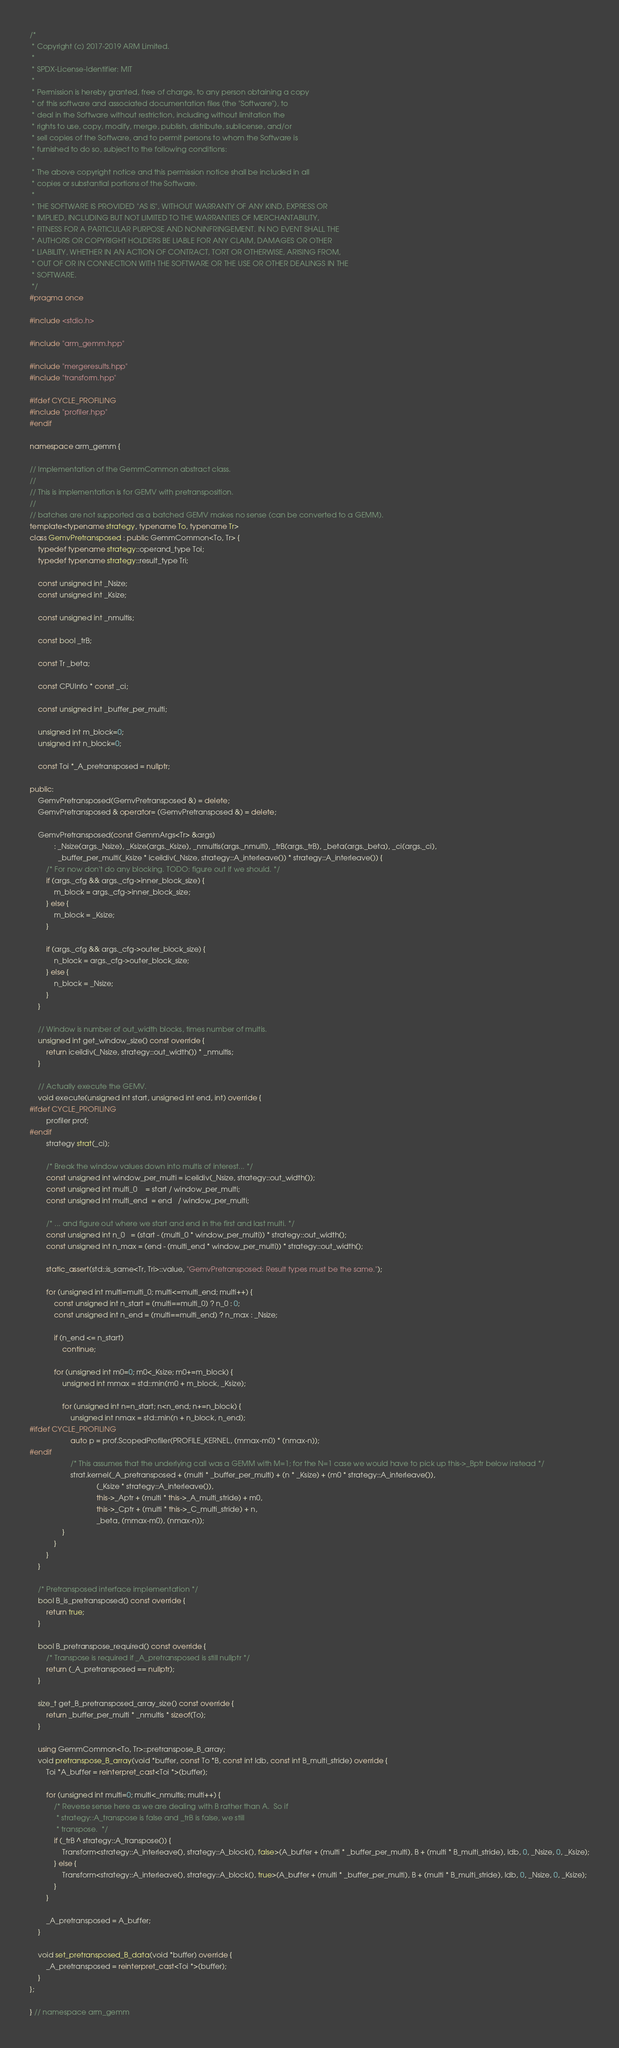<code> <loc_0><loc_0><loc_500><loc_500><_C++_>/*
 * Copyright (c) 2017-2019 ARM Limited.
 *
 * SPDX-License-Identifier: MIT
 *
 * Permission is hereby granted, free of charge, to any person obtaining a copy
 * of this software and associated documentation files (the "Software"), to
 * deal in the Software without restriction, including without limitation the
 * rights to use, copy, modify, merge, publish, distribute, sublicense, and/or
 * sell copies of the Software, and to permit persons to whom the Software is
 * furnished to do so, subject to the following conditions:
 *
 * The above copyright notice and this permission notice shall be included in all
 * copies or substantial portions of the Software.
 *
 * THE SOFTWARE IS PROVIDED "AS IS", WITHOUT WARRANTY OF ANY KIND, EXPRESS OR
 * IMPLIED, INCLUDING BUT NOT LIMITED TO THE WARRANTIES OF MERCHANTABILITY,
 * FITNESS FOR A PARTICULAR PURPOSE AND NONINFRINGEMENT. IN NO EVENT SHALL THE
 * AUTHORS OR COPYRIGHT HOLDERS BE LIABLE FOR ANY CLAIM, DAMAGES OR OTHER
 * LIABILITY, WHETHER IN AN ACTION OF CONTRACT, TORT OR OTHERWISE, ARISING FROM,
 * OUT OF OR IN CONNECTION WITH THE SOFTWARE OR THE USE OR OTHER DEALINGS IN THE
 * SOFTWARE.
 */
#pragma once

#include <stdio.h>

#include "arm_gemm.hpp"

#include "mergeresults.hpp"
#include "transform.hpp"

#ifdef CYCLE_PROFILING
#include "profiler.hpp"
#endif

namespace arm_gemm {

// Implementation of the GemmCommon abstract class.
//
// This is implementation is for GEMV with pretransposition.
//
// batches are not supported as a batched GEMV makes no sense (can be converted to a GEMM).
template<typename strategy, typename To, typename Tr>
class GemvPretransposed : public GemmCommon<To, Tr> {
    typedef typename strategy::operand_type Toi;
    typedef typename strategy::result_type Tri;

    const unsigned int _Nsize;
    const unsigned int _Ksize;

    const unsigned int _nmultis;

    const bool _trB;

    const Tr _beta;

    const CPUInfo * const _ci;

    const unsigned int _buffer_per_multi;

    unsigned int m_block=0;
    unsigned int n_block=0;

    const Toi *_A_pretransposed = nullptr;

public:
    GemvPretransposed(GemvPretransposed &) = delete;
    GemvPretransposed & operator= (GemvPretransposed &) = delete;

    GemvPretransposed(const GemmArgs<Tr> &args)
            : _Nsize(args._Nsize), _Ksize(args._Ksize), _nmultis(args._nmulti), _trB(args._trB), _beta(args._beta), _ci(args._ci),
              _buffer_per_multi(_Ksize * iceildiv(_Nsize, strategy::A_interleave()) * strategy::A_interleave()) {
        /* For now don't do any blocking. TODO: figure out if we should. */
        if (args._cfg && args._cfg->inner_block_size) {
            m_block = args._cfg->inner_block_size;
        } else {
            m_block = _Ksize;
        }

        if (args._cfg && args._cfg->outer_block_size) {
            n_block = args._cfg->outer_block_size;
        } else {
            n_block = _Nsize;
        }
    }

    // Window is number of out_width blocks, times number of multis.
    unsigned int get_window_size() const override {
        return iceildiv(_Nsize, strategy::out_width()) * _nmultis;
    }

    // Actually execute the GEMV.
    void execute(unsigned int start, unsigned int end, int) override {
#ifdef CYCLE_PROFILING
        profiler prof;
#endif
        strategy strat(_ci);

        /* Break the window values down into multis of interest... */
        const unsigned int window_per_multi = iceildiv(_Nsize, strategy::out_width());
        const unsigned int multi_0    = start / window_per_multi;
        const unsigned int multi_end  = end   / window_per_multi;

        /* ... and figure out where we start and end in the first and last multi. */
        const unsigned int n_0   = (start - (multi_0 * window_per_multi)) * strategy::out_width();
        const unsigned int n_max = (end - (multi_end * window_per_multi)) * strategy::out_width();

        static_assert(std::is_same<Tr, Tri>::value, "GemvPretransposed: Result types must be the same.");

        for (unsigned int multi=multi_0; multi<=multi_end; multi++) {
            const unsigned int n_start = (multi==multi_0) ? n_0 : 0;
            const unsigned int n_end = (multi==multi_end) ? n_max : _Nsize;

            if (n_end <= n_start)
                continue;

            for (unsigned int m0=0; m0<_Ksize; m0+=m_block) {
                unsigned int mmax = std::min(m0 + m_block, _Ksize);

                for (unsigned int n=n_start; n<n_end; n+=n_block) {
                    unsigned int nmax = std::min(n + n_block, n_end);
#ifdef CYCLE_PROFILING
                    auto p = prof.ScopedProfiler(PROFILE_KERNEL, (mmax-m0) * (nmax-n));
#endif
                    /* This assumes that the underlying call was a GEMM with M=1; for the N=1 case we would have to pick up this->_Bptr below instead */
                    strat.kernel(_A_pretransposed + (multi * _buffer_per_multi) + (n * _Ksize) + (m0 * strategy::A_interleave()),
                                 (_Ksize * strategy::A_interleave()),
                                 this->_Aptr + (multi * this->_A_multi_stride) + m0,
                                 this->_Cptr + (multi * this->_C_multi_stride) + n,
                                 _beta, (mmax-m0), (nmax-n));
                }
            }
        }
    }

    /* Pretransposed interface implementation */
    bool B_is_pretransposed() const override {
        return true;
    }

    bool B_pretranspose_required() const override {
        /* Transpose is required if _A_pretransposed is still nullptr */
        return (_A_pretransposed == nullptr);
    }

    size_t get_B_pretransposed_array_size() const override {
        return _buffer_per_multi * _nmultis * sizeof(To);
    }

    using GemmCommon<To, Tr>::pretranspose_B_array;
    void pretranspose_B_array(void *buffer, const To *B, const int ldb, const int B_multi_stride) override {
        Toi *A_buffer = reinterpret_cast<Toi *>(buffer);

        for (unsigned int multi=0; multi<_nmultis; multi++) {
            /* Reverse sense here as we are dealing with B rather than A.  So if
             * strategy::A_transpose is false and _trB is false, we still
             * transpose.  */
            if (_trB ^ strategy::A_transpose()) {
                Transform<strategy::A_interleave(), strategy::A_block(), false>(A_buffer + (multi * _buffer_per_multi), B + (multi * B_multi_stride), ldb, 0, _Nsize, 0, _Ksize);
            } else {
                Transform<strategy::A_interleave(), strategy::A_block(), true>(A_buffer + (multi * _buffer_per_multi), B + (multi * B_multi_stride), ldb, 0, _Nsize, 0, _Ksize);
            }
        }

        _A_pretransposed = A_buffer;
    }

    void set_pretransposed_B_data(void *buffer) override {
        _A_pretransposed = reinterpret_cast<Toi *>(buffer);
    }
};

} // namespace arm_gemm
</code> 